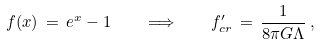<formula> <loc_0><loc_0><loc_500><loc_500>f ( x ) \, = \, e ^ { x } - 1 \quad \Longrightarrow \quad f _ { c r } ^ { \prime } \, = \, \frac { 1 } { 8 \pi G \Lambda } \, ,</formula> 